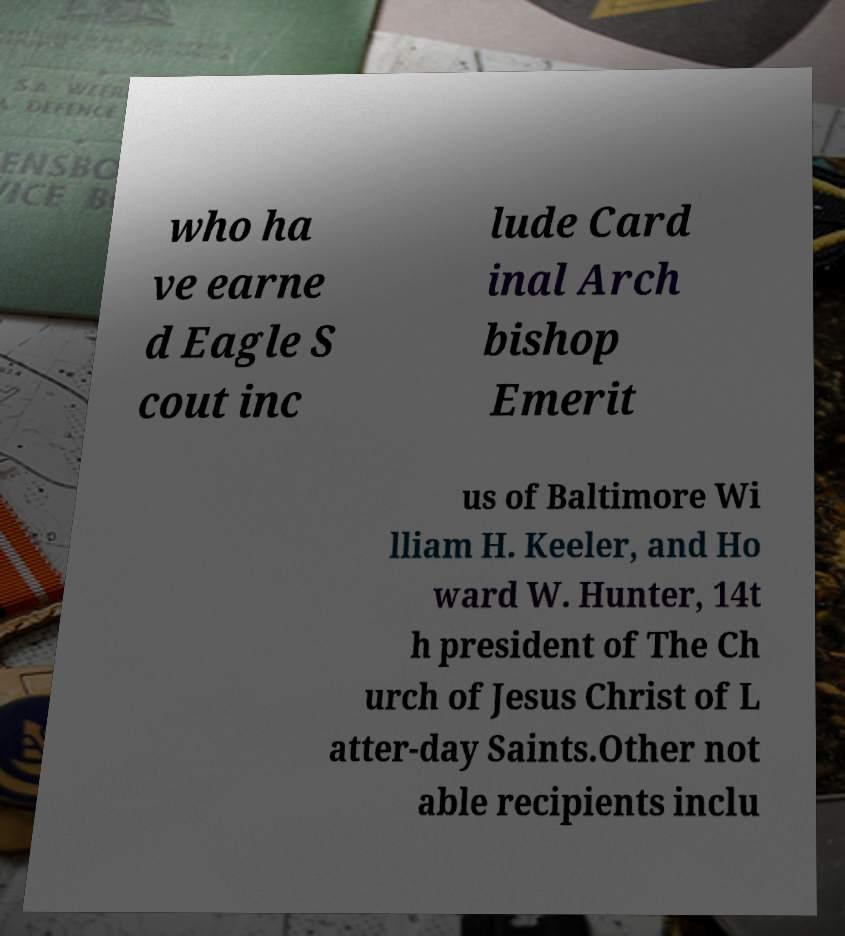I need the written content from this picture converted into text. Can you do that? who ha ve earne d Eagle S cout inc lude Card inal Arch bishop Emerit us of Baltimore Wi lliam H. Keeler, and Ho ward W. Hunter, 14t h president of The Ch urch of Jesus Christ of L atter-day Saints.Other not able recipients inclu 